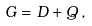<formula> <loc_0><loc_0><loc_500><loc_500>G = D + Q \, ,</formula> 